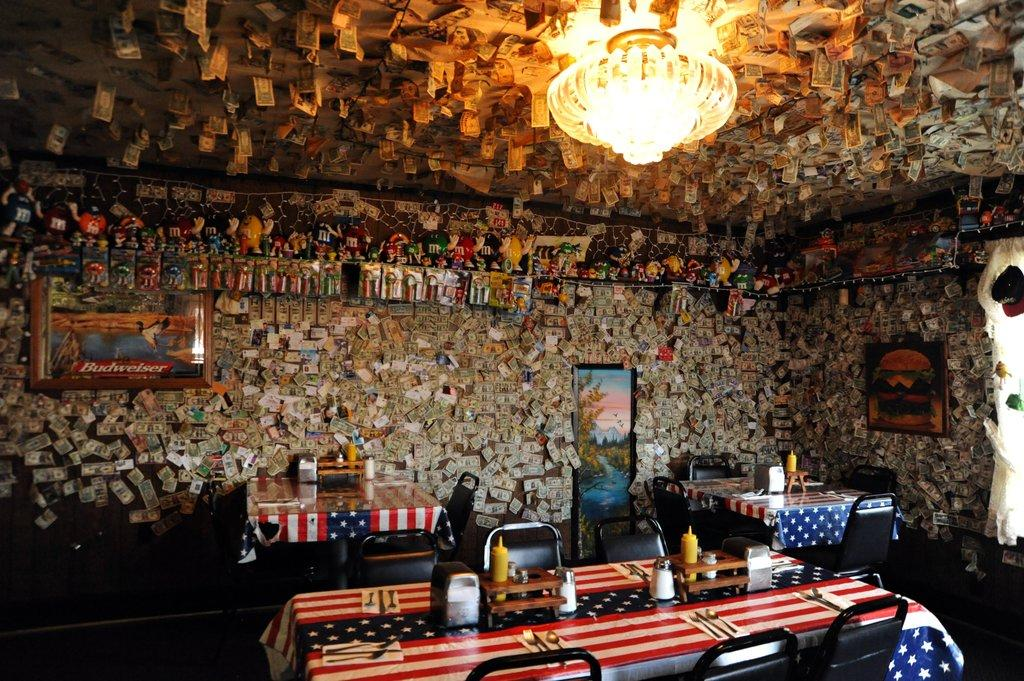What type of furniture is present in the image? There are chairs and dining tables in the image. What can be seen on the tables? There are bottles visible on the tables. What is on the wall in the background of the image? There are photo frames and other images on the wall in the background of the image. What is the source of light visible at the top of the image? There is a light visible at the top of the image. How does the business shake its leg in the image? There is no business or leg present in the image; it features chairs, dining tables, bottles, photo frames, other images, and a light. 